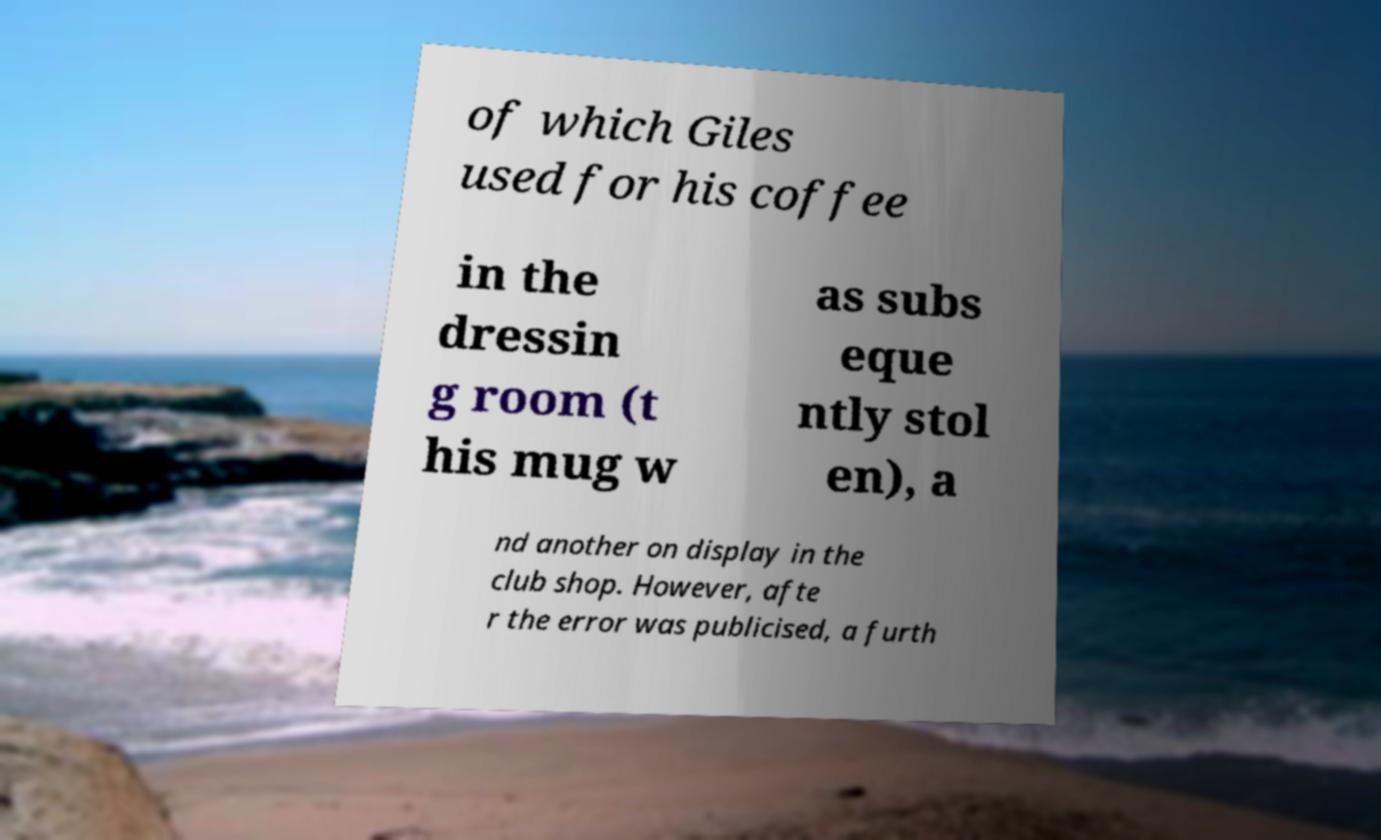Can you accurately transcribe the text from the provided image for me? of which Giles used for his coffee in the dressin g room (t his mug w as subs eque ntly stol en), a nd another on display in the club shop. However, afte r the error was publicised, a furth 